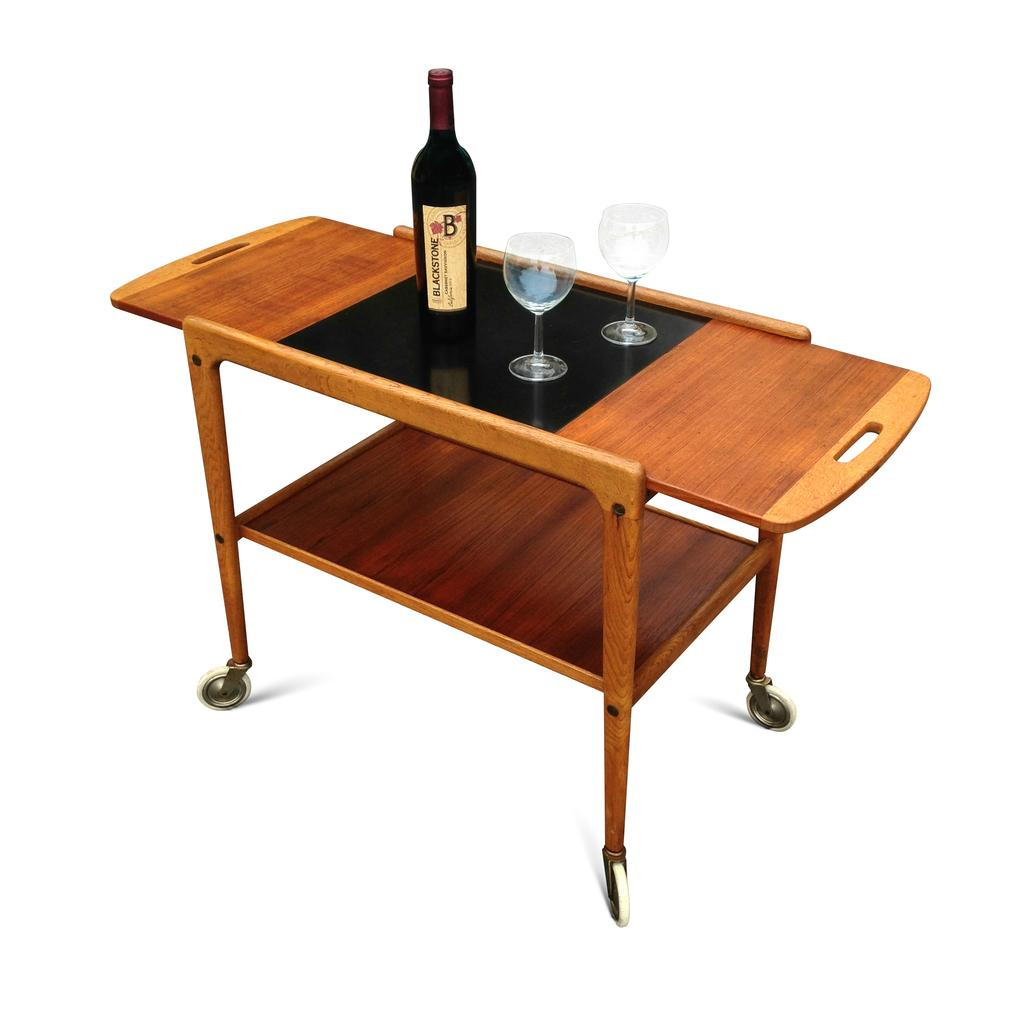What type of image is being described? The image is an animation. What object can be seen on the table in the image? There is a glass bottle on the table. How many glasses are beside the bottle on the table? There are two glasses beside the bottle on the table. What type of chalk is being used to draw on the table in the image? There is no chalk present in the image, and therefore no drawing on the table. 